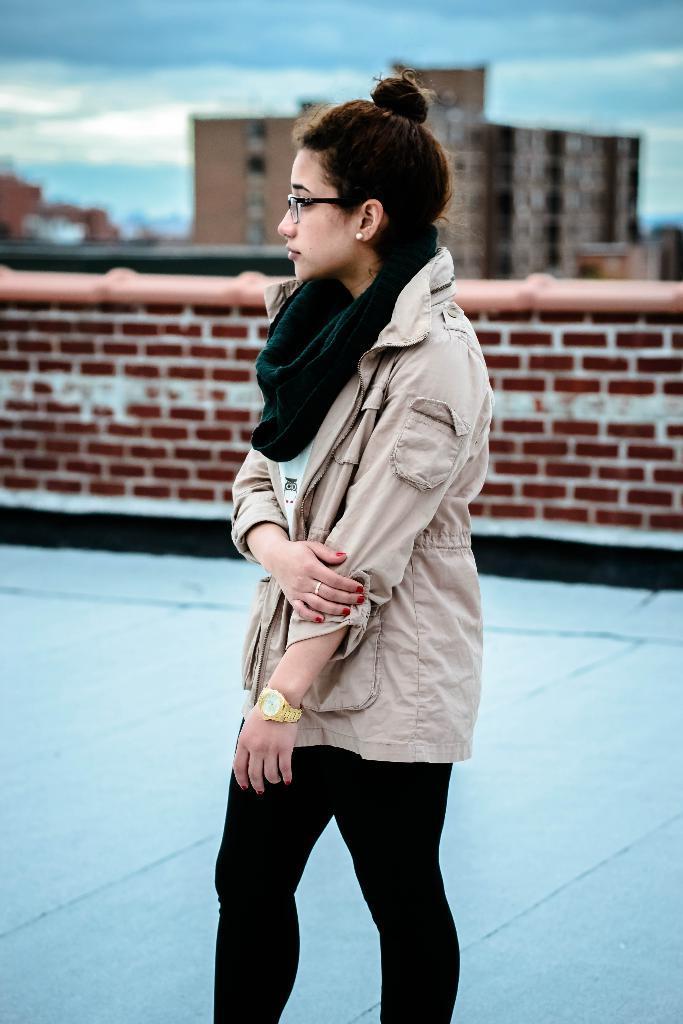Can you describe this image briefly? There is a woman in black color pant, standing on the floor. In the background, there is a brick wall, there is a building and there are clouds in the sky. 